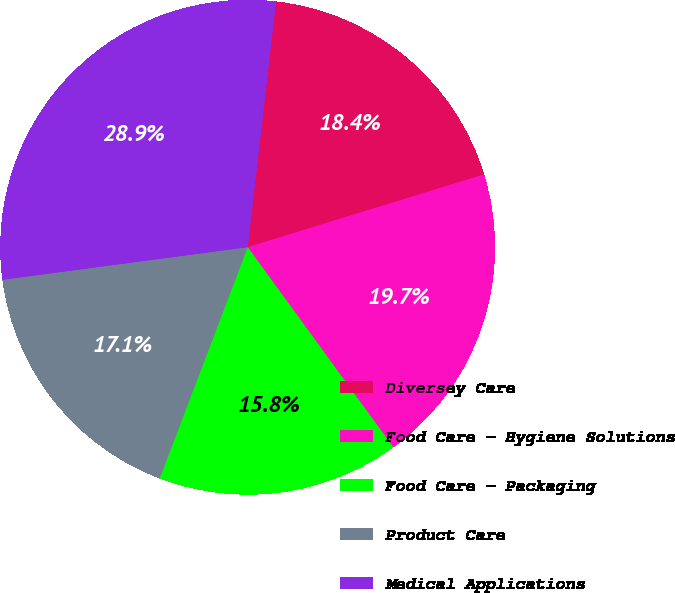Convert chart. <chart><loc_0><loc_0><loc_500><loc_500><pie_chart><fcel>Diversey Care<fcel>Food Care - Hygiene Solutions<fcel>Food Care - Packaging<fcel>Product Care<fcel>Medical Applications<nl><fcel>18.42%<fcel>19.74%<fcel>15.8%<fcel>17.11%<fcel>28.93%<nl></chart> 